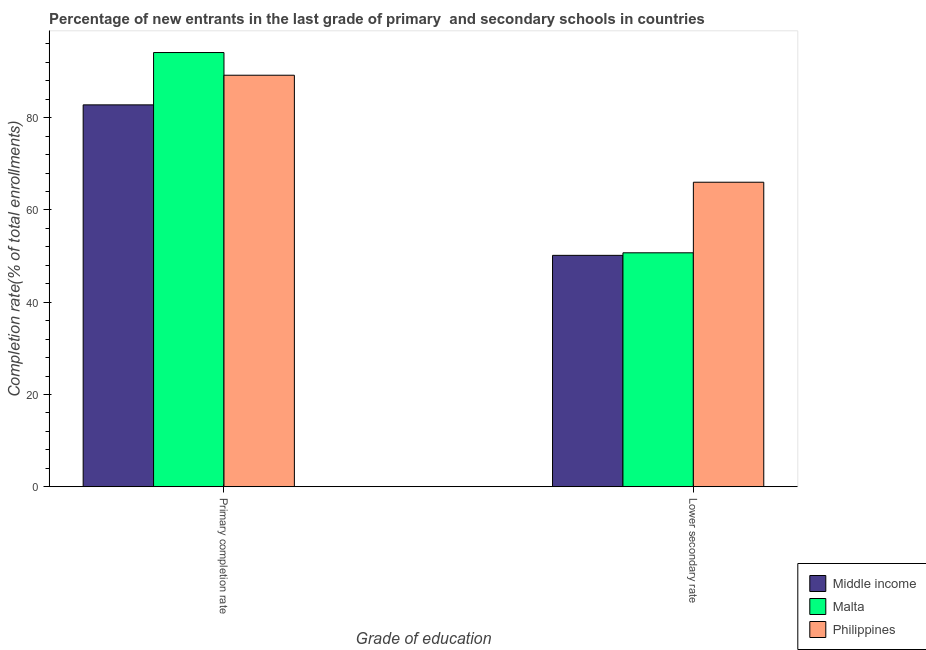How many different coloured bars are there?
Give a very brief answer. 3. Are the number of bars per tick equal to the number of legend labels?
Provide a succinct answer. Yes. How many bars are there on the 1st tick from the right?
Offer a terse response. 3. What is the label of the 2nd group of bars from the left?
Make the answer very short. Lower secondary rate. What is the completion rate in secondary schools in Middle income?
Offer a terse response. 50.16. Across all countries, what is the maximum completion rate in secondary schools?
Provide a short and direct response. 66.02. Across all countries, what is the minimum completion rate in primary schools?
Ensure brevity in your answer.  82.79. In which country was the completion rate in secondary schools minimum?
Your response must be concise. Middle income. What is the total completion rate in primary schools in the graph?
Your response must be concise. 266.13. What is the difference between the completion rate in primary schools in Middle income and that in Philippines?
Make the answer very short. -6.43. What is the difference between the completion rate in secondary schools in Middle income and the completion rate in primary schools in Malta?
Give a very brief answer. -43.97. What is the average completion rate in secondary schools per country?
Make the answer very short. 55.63. What is the difference between the completion rate in primary schools and completion rate in secondary schools in Philippines?
Your answer should be compact. 23.2. What is the ratio of the completion rate in secondary schools in Malta to that in Philippines?
Provide a short and direct response. 0.77. What does the 1st bar from the right in Lower secondary rate represents?
Provide a succinct answer. Philippines. How many bars are there?
Offer a terse response. 6. Are all the bars in the graph horizontal?
Give a very brief answer. No. What is the difference between two consecutive major ticks on the Y-axis?
Offer a very short reply. 20. Are the values on the major ticks of Y-axis written in scientific E-notation?
Your answer should be very brief. No. Where does the legend appear in the graph?
Provide a succinct answer. Bottom right. What is the title of the graph?
Provide a succinct answer. Percentage of new entrants in the last grade of primary  and secondary schools in countries. What is the label or title of the X-axis?
Your response must be concise. Grade of education. What is the label or title of the Y-axis?
Your response must be concise. Completion rate(% of total enrollments). What is the Completion rate(% of total enrollments) in Middle income in Primary completion rate?
Provide a succinct answer. 82.79. What is the Completion rate(% of total enrollments) in Malta in Primary completion rate?
Your answer should be very brief. 94.13. What is the Completion rate(% of total enrollments) of Philippines in Primary completion rate?
Your answer should be very brief. 89.21. What is the Completion rate(% of total enrollments) of Middle income in Lower secondary rate?
Make the answer very short. 50.16. What is the Completion rate(% of total enrollments) in Malta in Lower secondary rate?
Give a very brief answer. 50.71. What is the Completion rate(% of total enrollments) of Philippines in Lower secondary rate?
Your response must be concise. 66.02. Across all Grade of education, what is the maximum Completion rate(% of total enrollments) of Middle income?
Offer a very short reply. 82.79. Across all Grade of education, what is the maximum Completion rate(% of total enrollments) in Malta?
Make the answer very short. 94.13. Across all Grade of education, what is the maximum Completion rate(% of total enrollments) of Philippines?
Your response must be concise. 89.21. Across all Grade of education, what is the minimum Completion rate(% of total enrollments) in Middle income?
Make the answer very short. 50.16. Across all Grade of education, what is the minimum Completion rate(% of total enrollments) in Malta?
Your answer should be compact. 50.71. Across all Grade of education, what is the minimum Completion rate(% of total enrollments) in Philippines?
Keep it short and to the point. 66.02. What is the total Completion rate(% of total enrollments) in Middle income in the graph?
Make the answer very short. 132.95. What is the total Completion rate(% of total enrollments) of Malta in the graph?
Make the answer very short. 144.84. What is the total Completion rate(% of total enrollments) of Philippines in the graph?
Your response must be concise. 155.23. What is the difference between the Completion rate(% of total enrollments) in Middle income in Primary completion rate and that in Lower secondary rate?
Your answer should be compact. 32.62. What is the difference between the Completion rate(% of total enrollments) of Malta in Primary completion rate and that in Lower secondary rate?
Keep it short and to the point. 43.42. What is the difference between the Completion rate(% of total enrollments) of Philippines in Primary completion rate and that in Lower secondary rate?
Offer a terse response. 23.2. What is the difference between the Completion rate(% of total enrollments) in Middle income in Primary completion rate and the Completion rate(% of total enrollments) in Malta in Lower secondary rate?
Offer a very short reply. 32.07. What is the difference between the Completion rate(% of total enrollments) of Middle income in Primary completion rate and the Completion rate(% of total enrollments) of Philippines in Lower secondary rate?
Offer a very short reply. 16.77. What is the difference between the Completion rate(% of total enrollments) of Malta in Primary completion rate and the Completion rate(% of total enrollments) of Philippines in Lower secondary rate?
Your answer should be compact. 28.12. What is the average Completion rate(% of total enrollments) of Middle income per Grade of education?
Make the answer very short. 66.47. What is the average Completion rate(% of total enrollments) in Malta per Grade of education?
Offer a terse response. 72.42. What is the average Completion rate(% of total enrollments) in Philippines per Grade of education?
Your response must be concise. 77.61. What is the difference between the Completion rate(% of total enrollments) in Middle income and Completion rate(% of total enrollments) in Malta in Primary completion rate?
Give a very brief answer. -11.35. What is the difference between the Completion rate(% of total enrollments) of Middle income and Completion rate(% of total enrollments) of Philippines in Primary completion rate?
Your response must be concise. -6.43. What is the difference between the Completion rate(% of total enrollments) of Malta and Completion rate(% of total enrollments) of Philippines in Primary completion rate?
Your answer should be compact. 4.92. What is the difference between the Completion rate(% of total enrollments) in Middle income and Completion rate(% of total enrollments) in Malta in Lower secondary rate?
Provide a short and direct response. -0.55. What is the difference between the Completion rate(% of total enrollments) in Middle income and Completion rate(% of total enrollments) in Philippines in Lower secondary rate?
Keep it short and to the point. -15.85. What is the difference between the Completion rate(% of total enrollments) of Malta and Completion rate(% of total enrollments) of Philippines in Lower secondary rate?
Offer a terse response. -15.3. What is the ratio of the Completion rate(% of total enrollments) in Middle income in Primary completion rate to that in Lower secondary rate?
Give a very brief answer. 1.65. What is the ratio of the Completion rate(% of total enrollments) of Malta in Primary completion rate to that in Lower secondary rate?
Your answer should be very brief. 1.86. What is the ratio of the Completion rate(% of total enrollments) of Philippines in Primary completion rate to that in Lower secondary rate?
Offer a terse response. 1.35. What is the difference between the highest and the second highest Completion rate(% of total enrollments) of Middle income?
Offer a very short reply. 32.62. What is the difference between the highest and the second highest Completion rate(% of total enrollments) in Malta?
Ensure brevity in your answer.  43.42. What is the difference between the highest and the second highest Completion rate(% of total enrollments) in Philippines?
Your response must be concise. 23.2. What is the difference between the highest and the lowest Completion rate(% of total enrollments) of Middle income?
Offer a very short reply. 32.62. What is the difference between the highest and the lowest Completion rate(% of total enrollments) in Malta?
Offer a terse response. 43.42. What is the difference between the highest and the lowest Completion rate(% of total enrollments) of Philippines?
Your response must be concise. 23.2. 